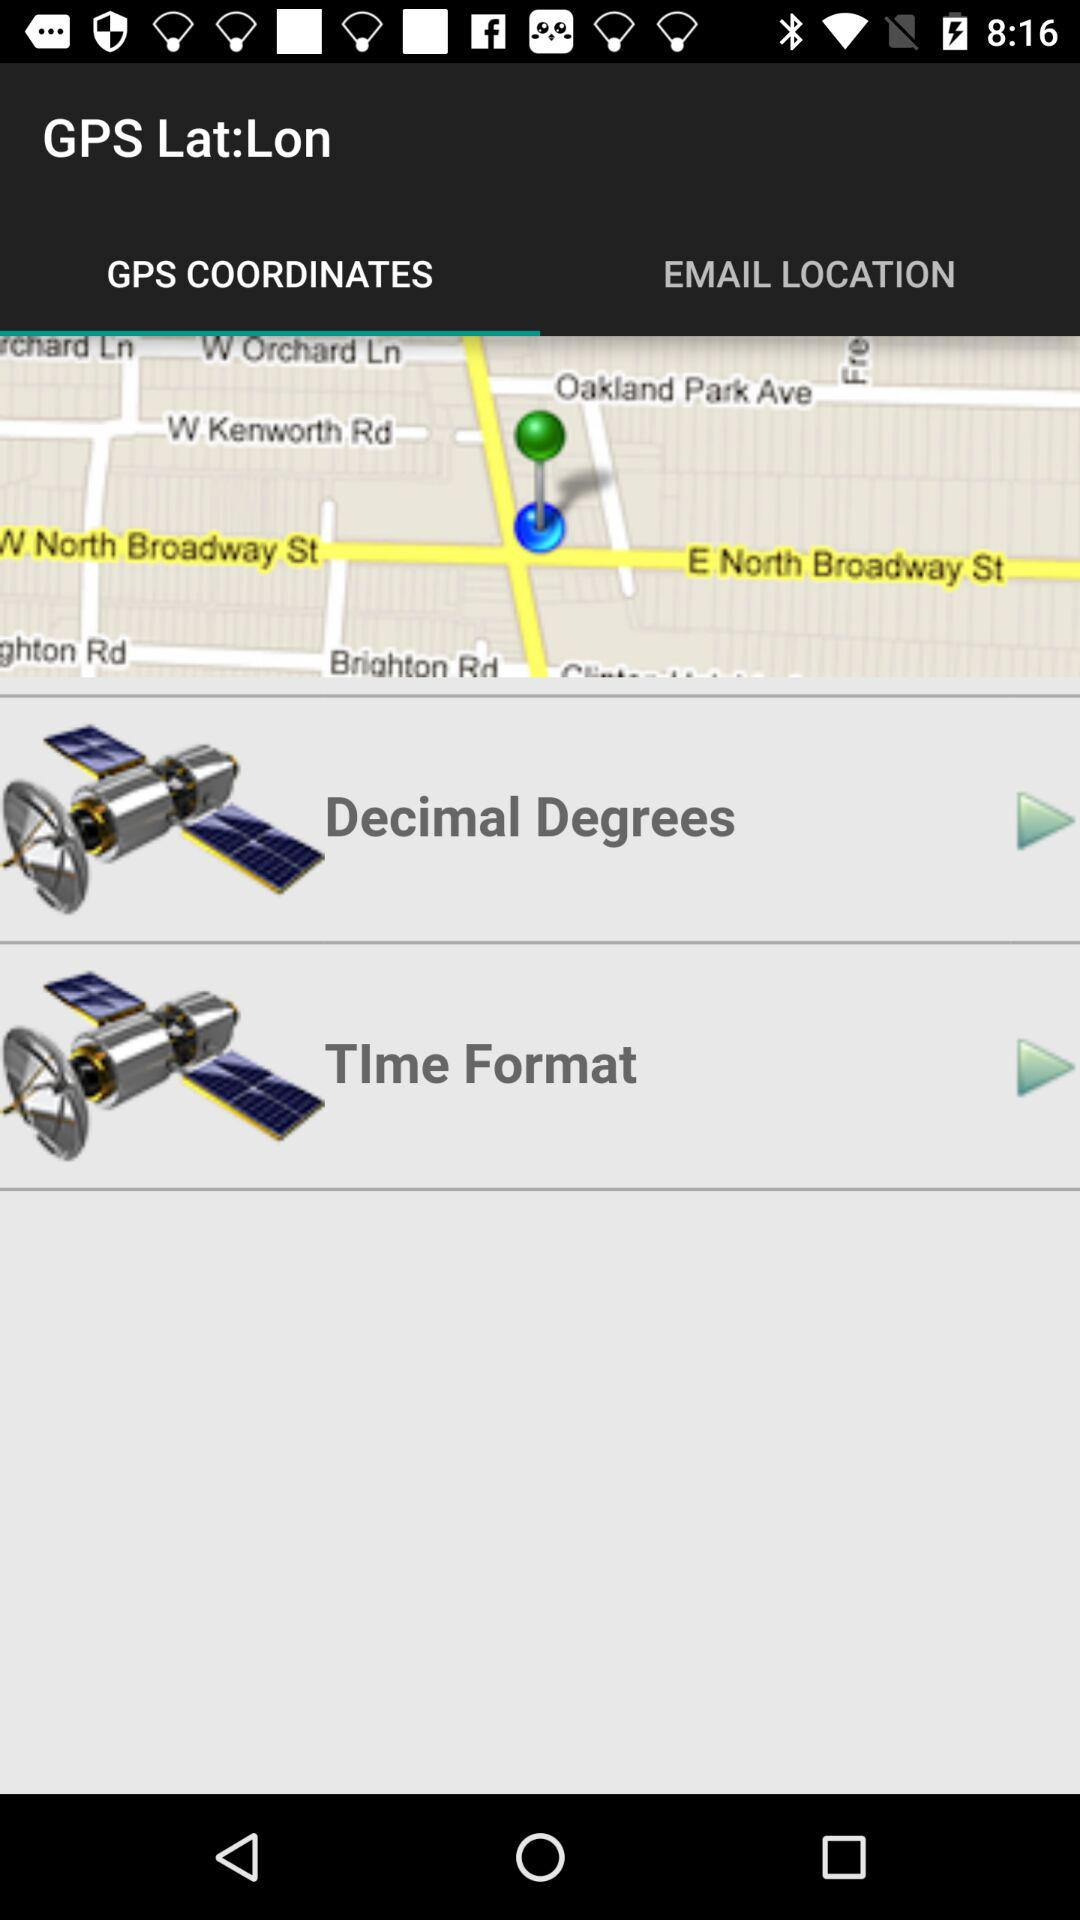Which tab is selected?
When the provided information is insufficient, respond with <no answer>. <no answer> 